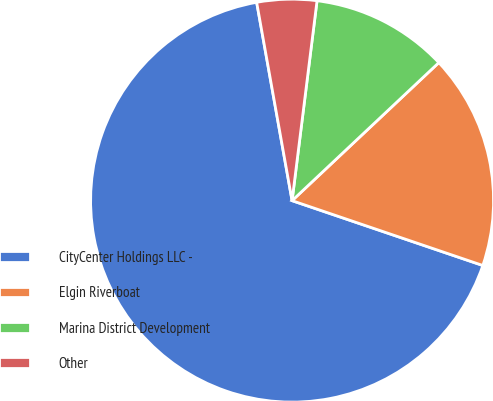Convert chart to OTSL. <chart><loc_0><loc_0><loc_500><loc_500><pie_chart><fcel>CityCenter Holdings LLC -<fcel>Elgin Riverboat<fcel>Marina District Development<fcel>Other<nl><fcel>66.98%<fcel>17.23%<fcel>11.01%<fcel>4.79%<nl></chart> 